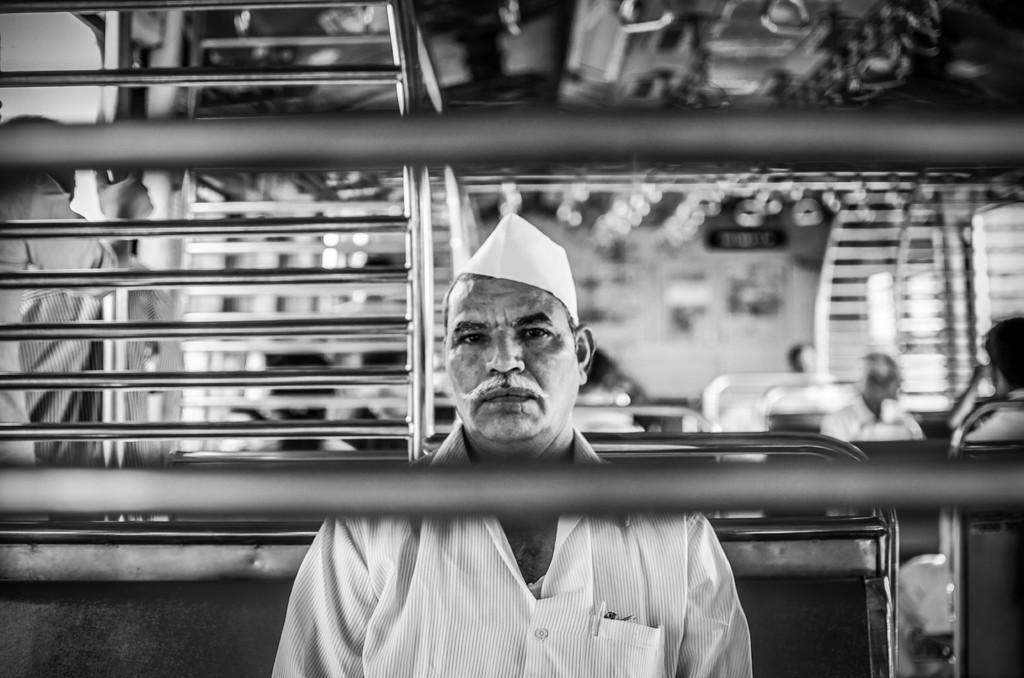Describe this image in one or two sentences. In this image I can see two iron bars like things in the front. In the background I can see number of people are sitting. I can also see number of iron poles on the both sides of the image and I can see this image is little bit blurry. In the front I can see a man is wearing a cap. I can also see this image is black and white in colour. 